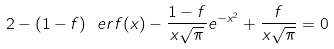<formula> <loc_0><loc_0><loc_500><loc_500>2 - ( 1 - f ) \ e r f ( x ) - \frac { 1 - f } { x \sqrt { \pi } } e ^ { - x ^ { 2 } } + \frac { f } { x \sqrt { \pi } } = 0</formula> 